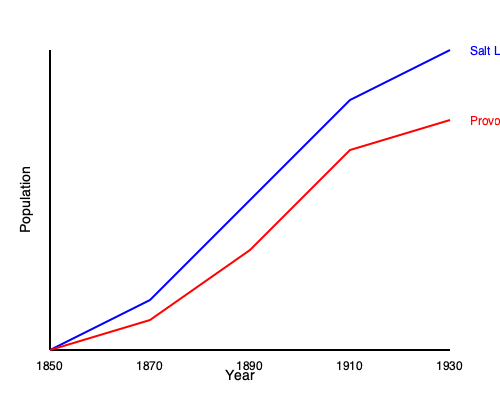Based on the line graph showing population growth in two Mormon settlements in Utah from 1850 to 1930, what can be inferred about the relative rates of growth between Salt Lake City and Provo, and how might this relate to their roles in early Mormon history? To answer this question, let's analyze the graph step-by-step:

1. Identify the lines: Blue represents Salt Lake City, and red represents Provo.

2. Compare starting points (1850):
   - Both cities start with relatively low populations.
   - Salt Lake City's population is slightly higher, which aligns with its status as the first major Mormon settlement in Utah, founded in 1847.

3. Analyze growth patterns:
   - Salt Lake City (blue line) shows a steeper, more consistent upward trajectory.
   - Provo (red line) grows more gradually, with a less steep slope.

4. Compare end points (1930):
   - Salt Lake City's population is significantly higher than Provo's.
   - The gap between the two cities has widened considerably since 1850.

5. Historical context:
   - Salt Lake City was the headquarters of the LDS Church and the territorial capital, which likely contributed to its faster growth.
   - Provo, founded in 1849, was an important secondary settlement but didn't have the same political and religious significance.

6. Inference:
   - Salt Lake City's faster growth rate suggests it was the primary destination for Mormon immigrants and converts.
   - Provo's steady but slower growth indicates it played a supporting role in Mormon expansion, possibly as an agricultural center or overflow settlement.

The graph illustrates the centrality of Salt Lake City in Mormon colonization efforts and the hierarchical nature of Mormon settlements in Utah during this period.
Answer: Salt Lake City grew faster than Provo, reflecting its central role in Mormon history as the church headquarters and territorial capital. 